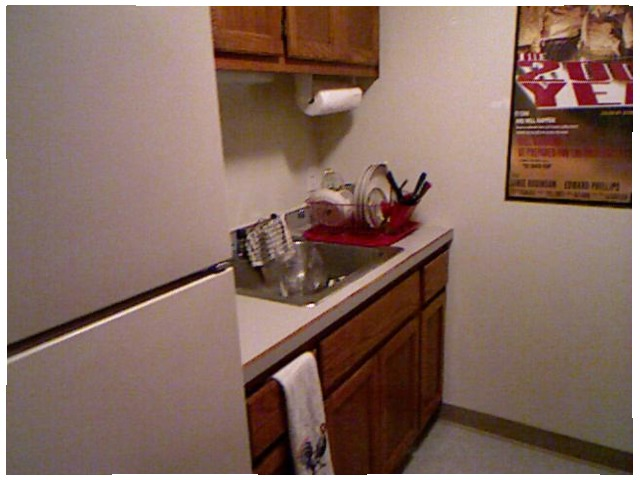<image>
Is there a paper towels to the right of the dish towel? Yes. From this viewpoint, the paper towels is positioned to the right side relative to the dish towel. Is there a towel under the sink? No. The towel is not positioned under the sink. The vertical relationship between these objects is different. Is there a dish towel in the drawer? Yes. The dish towel is contained within or inside the drawer, showing a containment relationship. 